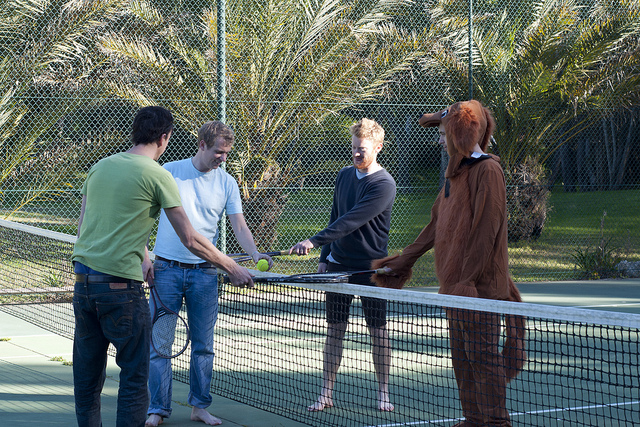Please provide a short description for this region: [0.58, 0.32, 0.82, 0.83]. A person wearing a brown dog costume. 